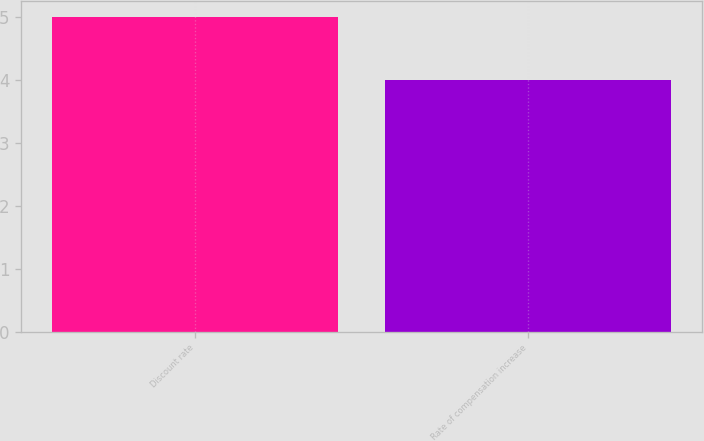<chart> <loc_0><loc_0><loc_500><loc_500><bar_chart><fcel>Discount rate<fcel>Rate of compensation increase<nl><fcel>5<fcel>4<nl></chart> 